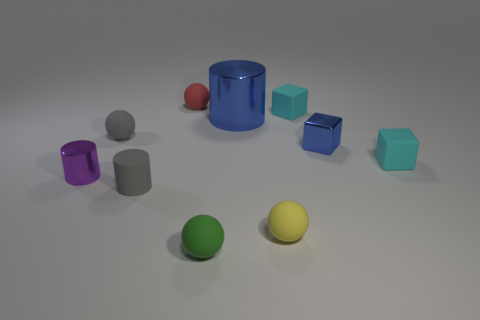There is a tiny sphere that is in front of the matte ball right of the green ball; are there any small balls to the left of it?
Offer a terse response. Yes. There is a tiny cylinder that is to the right of the gray sphere; is its color the same as the tiny matte object that is left of the tiny matte cylinder?
Offer a terse response. Yes. What material is the gray ball that is the same size as the red sphere?
Provide a succinct answer. Rubber. What is the size of the cyan thing that is in front of the small matte ball that is left of the gray cylinder that is to the right of the purple metal cylinder?
Give a very brief answer. Small. How many other things are there of the same material as the gray cylinder?
Make the answer very short. 6. How big is the green sphere in front of the tiny purple shiny cylinder?
Offer a terse response. Small. How many small things are behind the green ball and to the left of the large thing?
Make the answer very short. 4. There is a small cube that is left of the tiny blue block behind the tiny yellow rubber thing; what is its material?
Your answer should be very brief. Rubber. There is a yellow thing that is the same shape as the small green matte object; what material is it?
Offer a terse response. Rubber. Are any green cubes visible?
Offer a very short reply. No. 